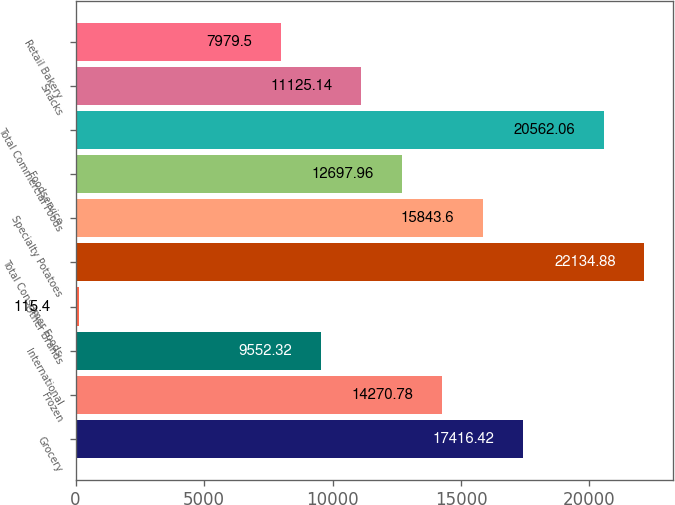Convert chart to OTSL. <chart><loc_0><loc_0><loc_500><loc_500><bar_chart><fcel>Grocery<fcel>Frozen<fcel>International<fcel>Other Brands<fcel>Total Consumer Foods<fcel>Specialty Potatoes<fcel>Foodservice<fcel>Total Commercial Foods<fcel>Snacks<fcel>Retail Bakery<nl><fcel>17416.4<fcel>14270.8<fcel>9552.32<fcel>115.4<fcel>22134.9<fcel>15843.6<fcel>12698<fcel>20562.1<fcel>11125.1<fcel>7979.5<nl></chart> 